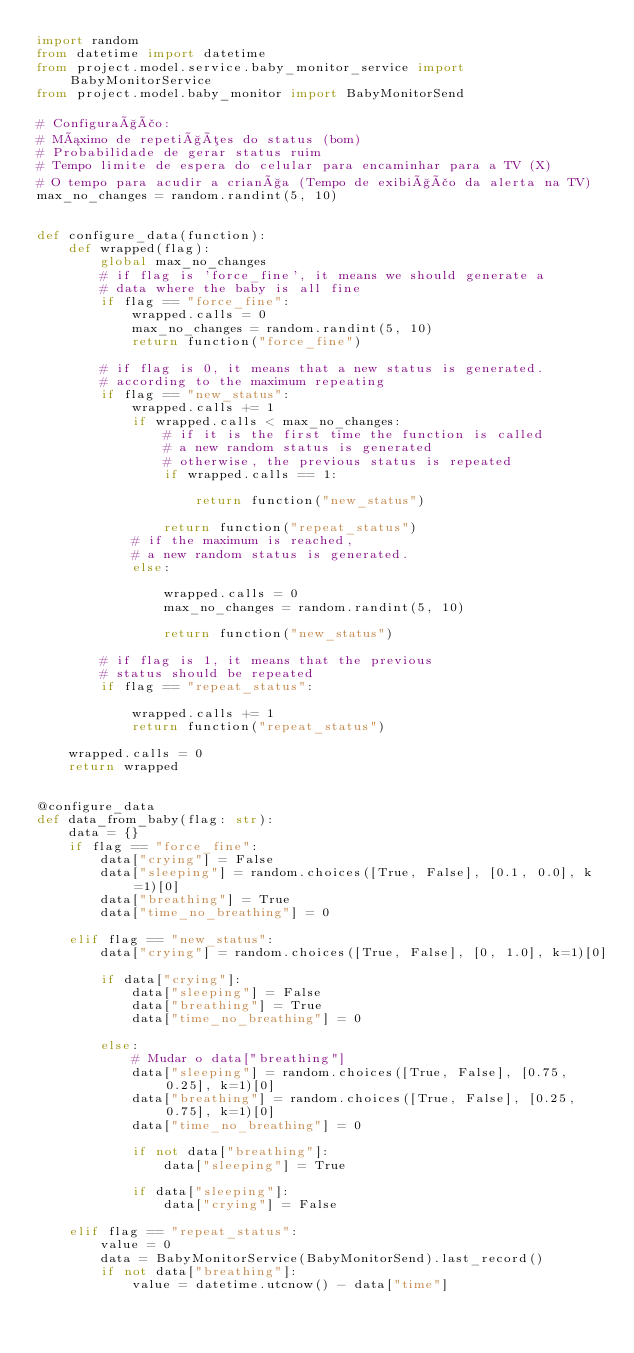<code> <loc_0><loc_0><loc_500><loc_500><_Python_>import random
from datetime import datetime
from project.model.service.baby_monitor_service import BabyMonitorService
from project.model.baby_monitor import BabyMonitorSend

# Configuração:
# Máximo de repetições do status (bom)
# Probabilidade de gerar status ruim
# Tempo limite de espera do celular para encaminhar para a TV (X)
# O tempo para acudir a criança (Tempo de exibição da alerta na TV)
max_no_changes = random.randint(5, 10)


def configure_data(function):
    def wrapped(flag):
        global max_no_changes
        # if flag is 'force_fine', it means we should generate a
        # data where the baby is all fine
        if flag == "force_fine":
            wrapped.calls = 0
            max_no_changes = random.randint(5, 10)
            return function("force_fine")

        # if flag is 0, it means that a new status is generated.
        # according to the maximum repeating
        if flag == "new_status":
            wrapped.calls += 1
            if wrapped.calls < max_no_changes:
                # if it is the first time the function is called
                # a new random status is generated
                # otherwise, the previous status is repeated
                if wrapped.calls == 1:

                    return function("new_status")

                return function("repeat_status")
            # if the maximum is reached,
            # a new random status is generated.
            else:

                wrapped.calls = 0
                max_no_changes = random.randint(5, 10)

                return function("new_status")

        # if flag is 1, it means that the previous
        # status should be repeated
        if flag == "repeat_status":

            wrapped.calls += 1
            return function("repeat_status")

    wrapped.calls = 0
    return wrapped


@configure_data
def data_from_baby(flag: str):
    data = {}
    if flag == "force_fine":
        data["crying"] = False
        data["sleeping"] = random.choices([True, False], [0.1, 0.0], k=1)[0]
        data["breathing"] = True
        data["time_no_breathing"] = 0

    elif flag == "new_status":
        data["crying"] = random.choices([True, False], [0, 1.0], k=1)[0]

        if data["crying"]:
            data["sleeping"] = False
            data["breathing"] = True
            data["time_no_breathing"] = 0

        else:
            # Mudar o data["breathing"]
            data["sleeping"] = random.choices([True, False], [0.75, 0.25], k=1)[0]
            data["breathing"] = random.choices([True, False], [0.25, 0.75], k=1)[0]
            data["time_no_breathing"] = 0

            if not data["breathing"]:
                data["sleeping"] = True

            if data["sleeping"]:
                data["crying"] = False

    elif flag == "repeat_status":
        value = 0
        data = BabyMonitorService(BabyMonitorSend).last_record()
        if not data["breathing"]:
            value = datetime.utcnow() - data["time"]</code> 